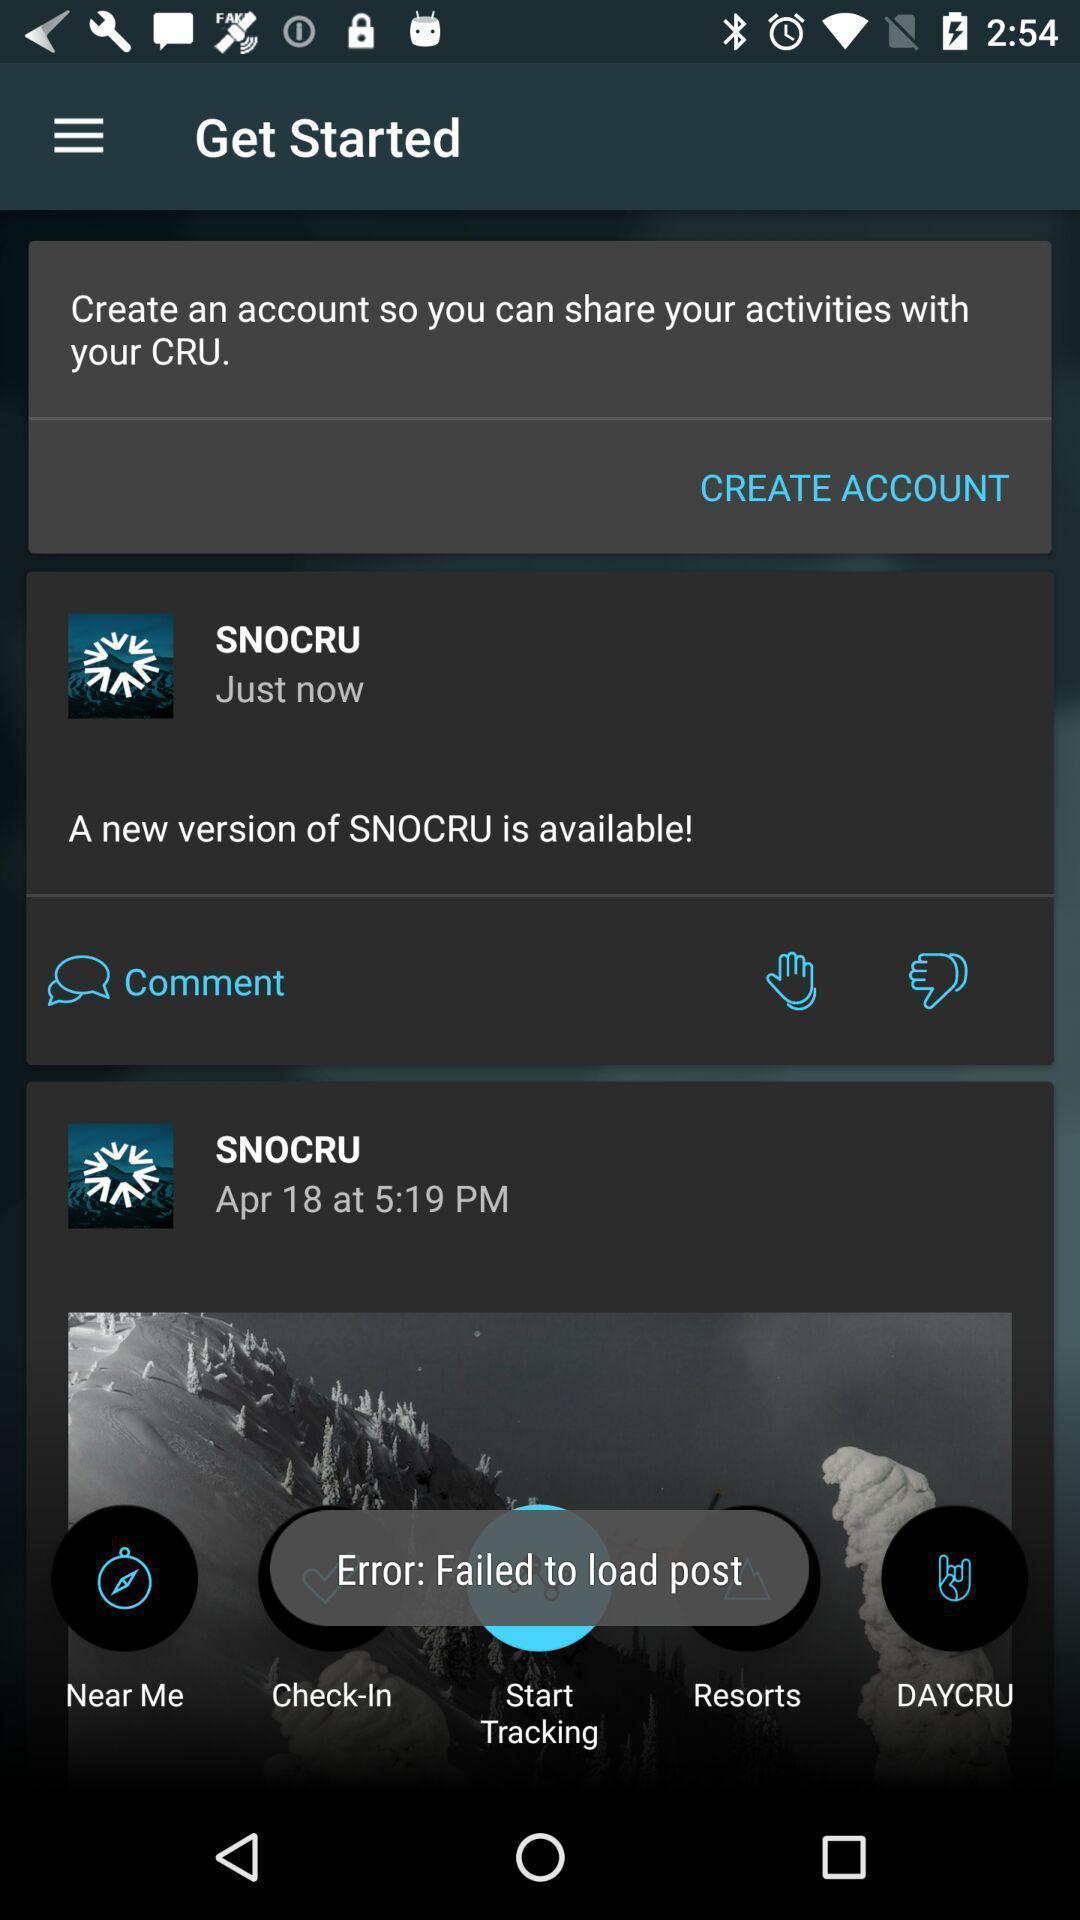Summarize the main components in this picture. Starting page of snow sports app. 